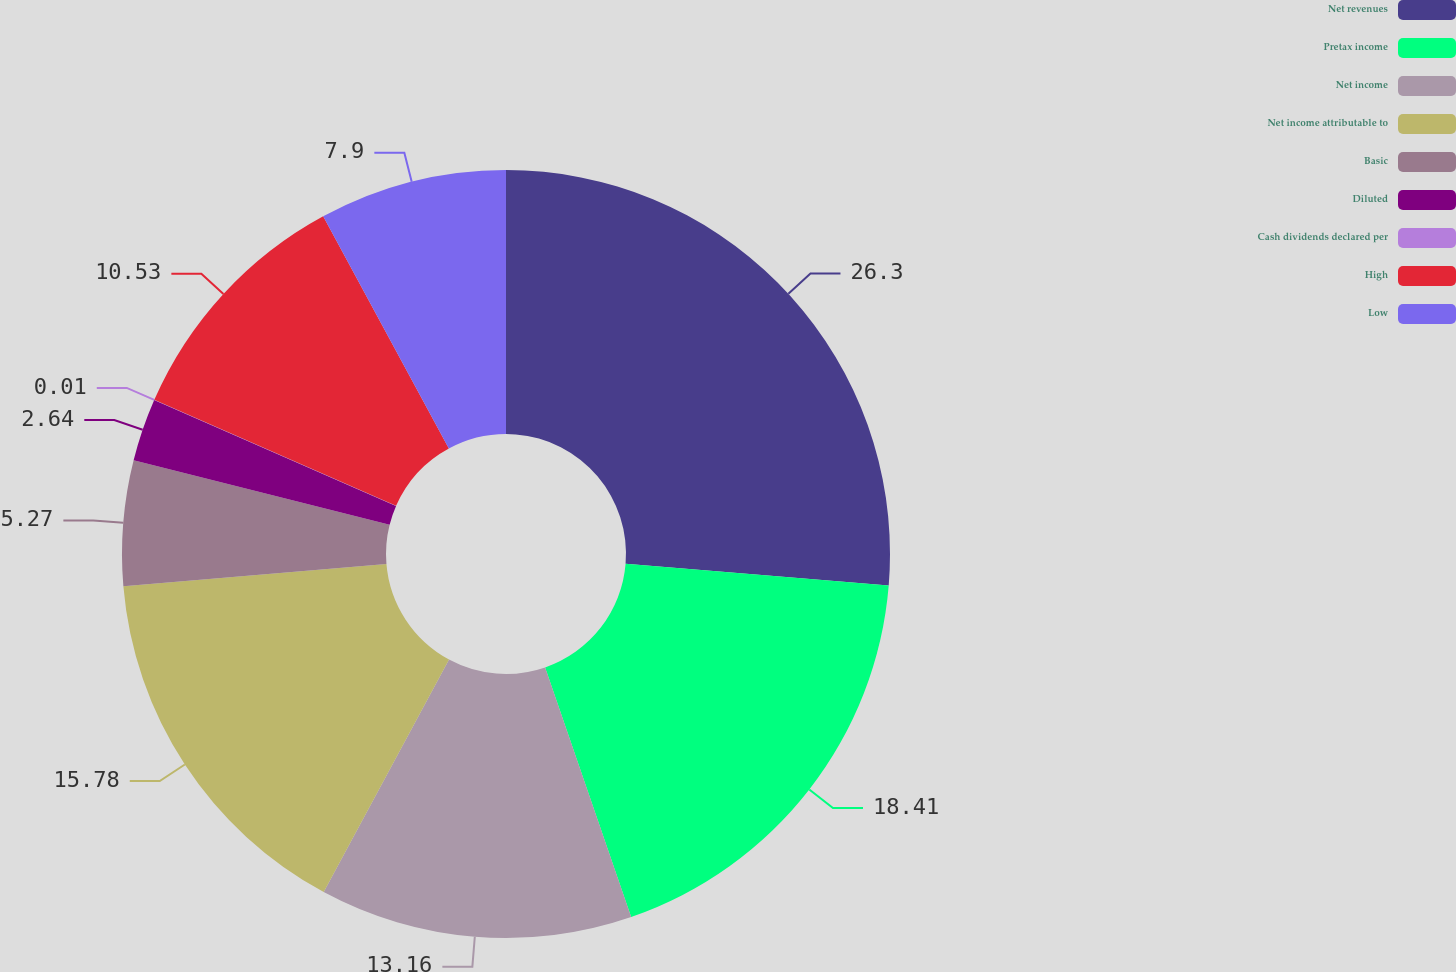Convert chart. <chart><loc_0><loc_0><loc_500><loc_500><pie_chart><fcel>Net revenues<fcel>Pretax income<fcel>Net income<fcel>Net income attributable to<fcel>Basic<fcel>Diluted<fcel>Cash dividends declared per<fcel>High<fcel>Low<nl><fcel>26.31%<fcel>18.42%<fcel>13.16%<fcel>15.79%<fcel>5.27%<fcel>2.64%<fcel>0.01%<fcel>10.53%<fcel>7.9%<nl></chart> 